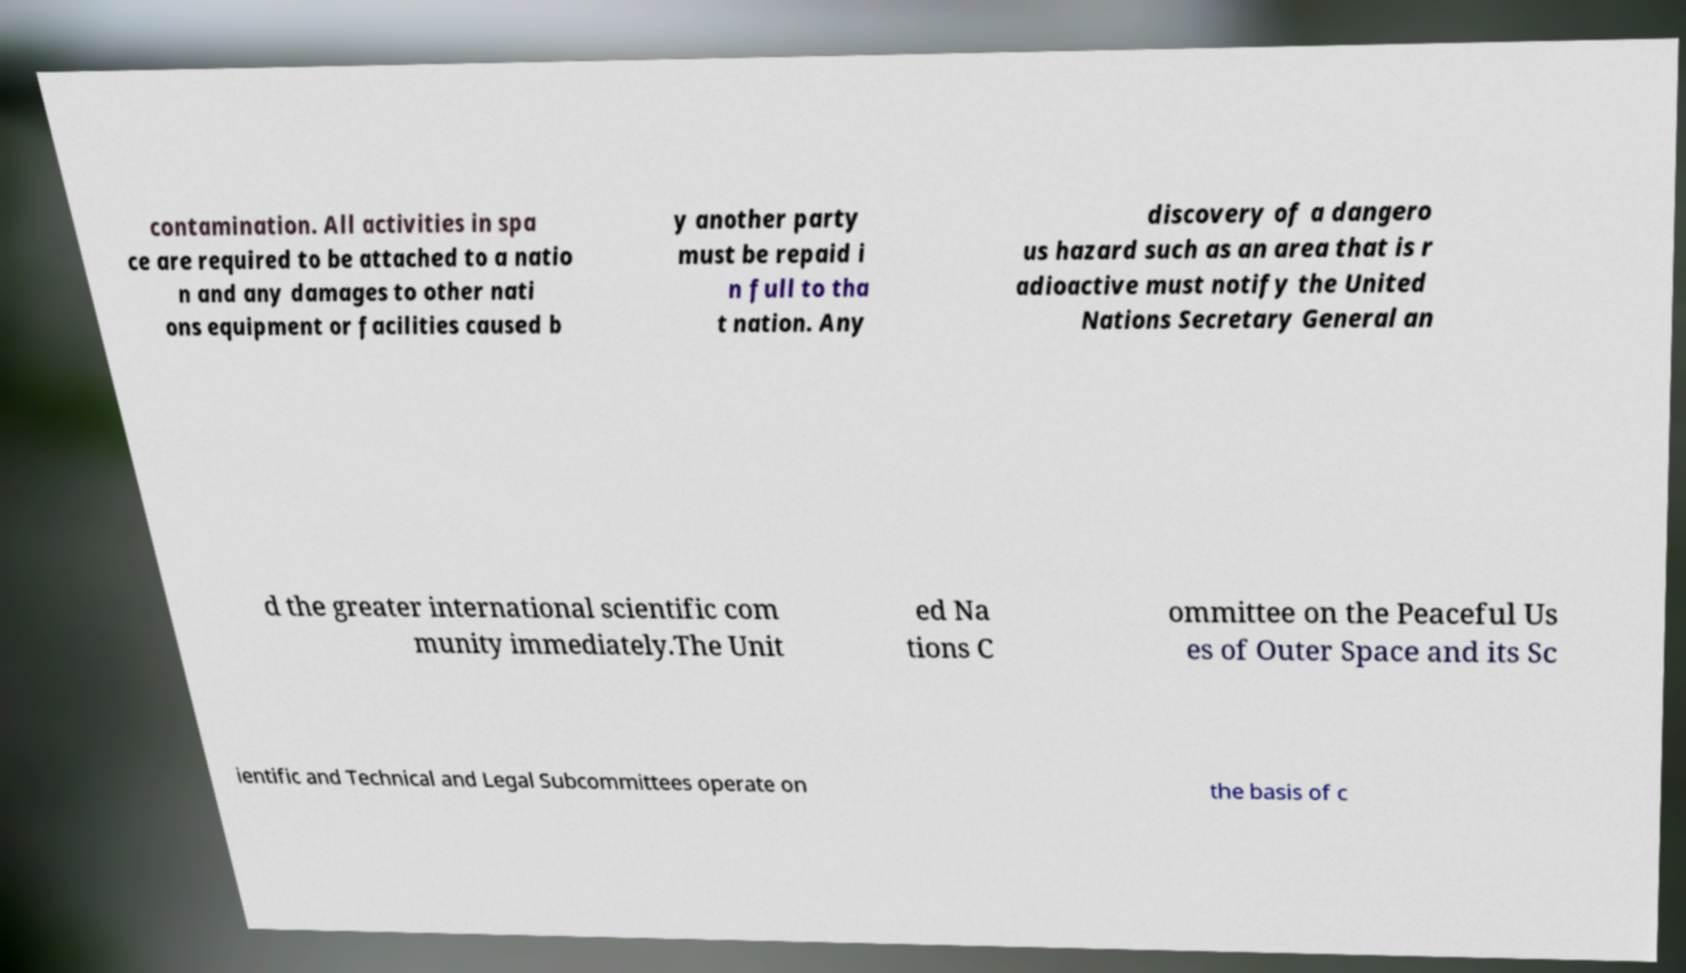There's text embedded in this image that I need extracted. Can you transcribe it verbatim? contamination. All activities in spa ce are required to be attached to a natio n and any damages to other nati ons equipment or facilities caused b y another party must be repaid i n full to tha t nation. Any discovery of a dangero us hazard such as an area that is r adioactive must notify the United Nations Secretary General an d the greater international scientific com munity immediately.The Unit ed Na tions C ommittee on the Peaceful Us es of Outer Space and its Sc ientific and Technical and Legal Subcommittees operate on the basis of c 